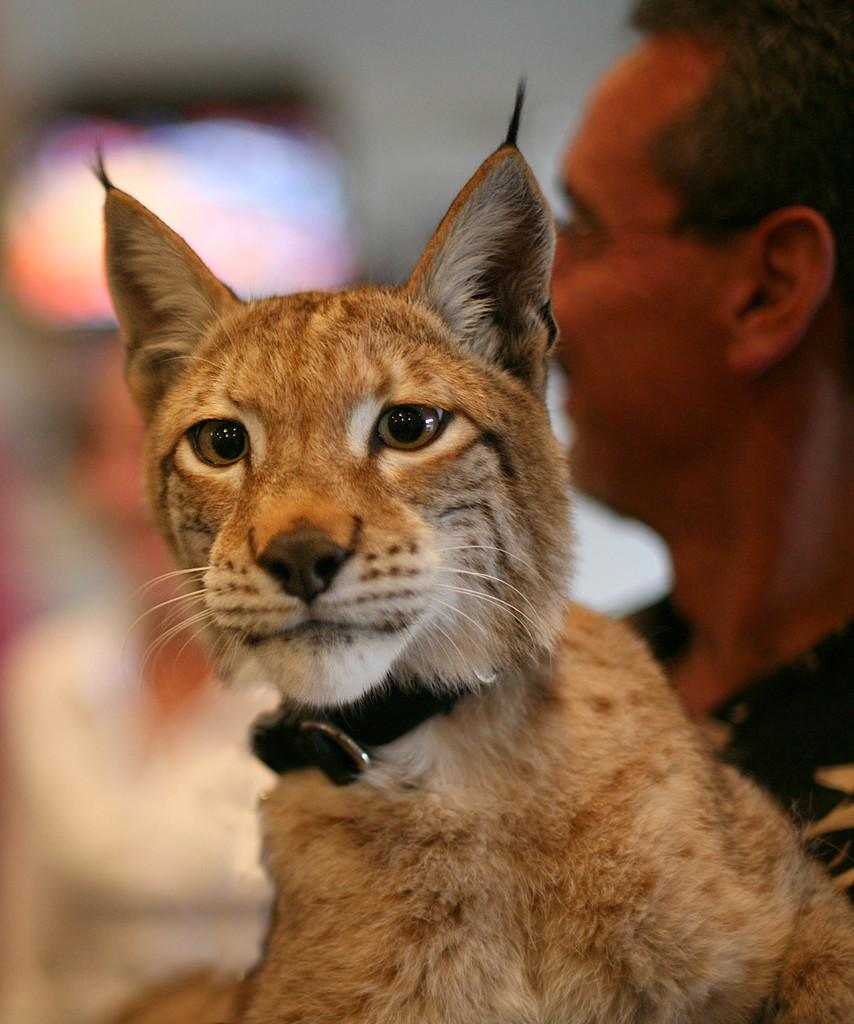What animal is in the front of the image? There is a cat in the front of the image. Who else is present in the image besides the cat? There is a man on the right side of the image, and there is another person in the background of the image. Can you describe the background of the image? The background of the image appears blurry. How many spots can be seen on the cat in the image? There is no mention of spots on the cat in the image, so it cannot be determined from the provided facts. 